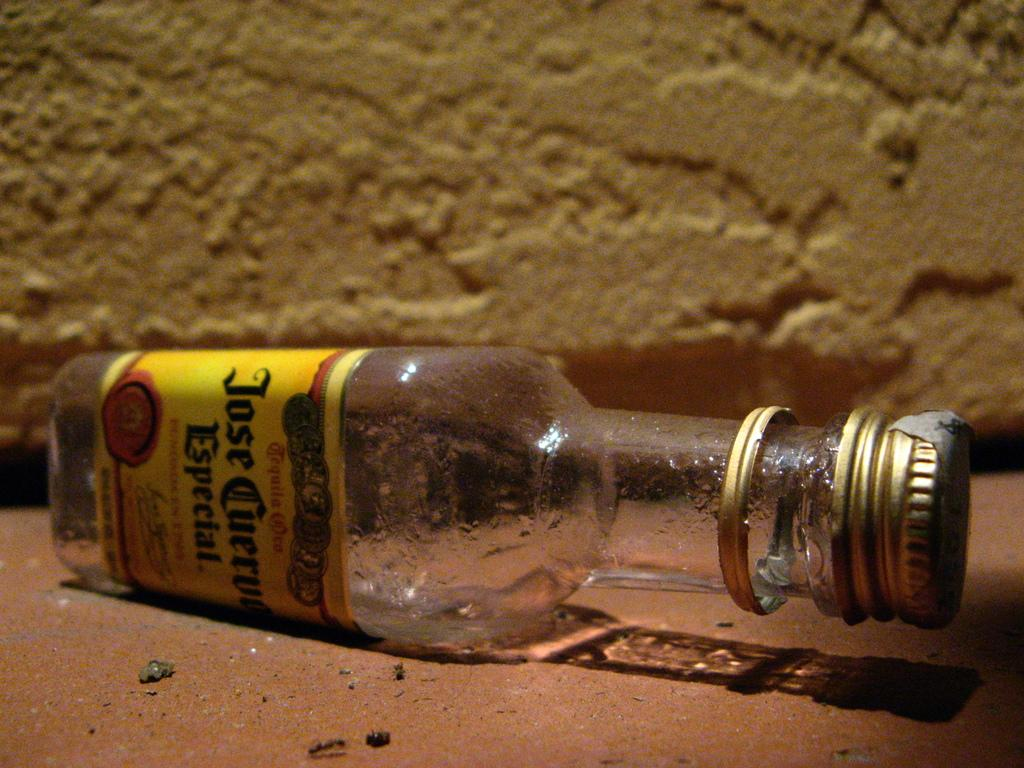<image>
Render a clear and concise summary of the photo. an old empty bottle of Jose Cuervo Especial on a floor 